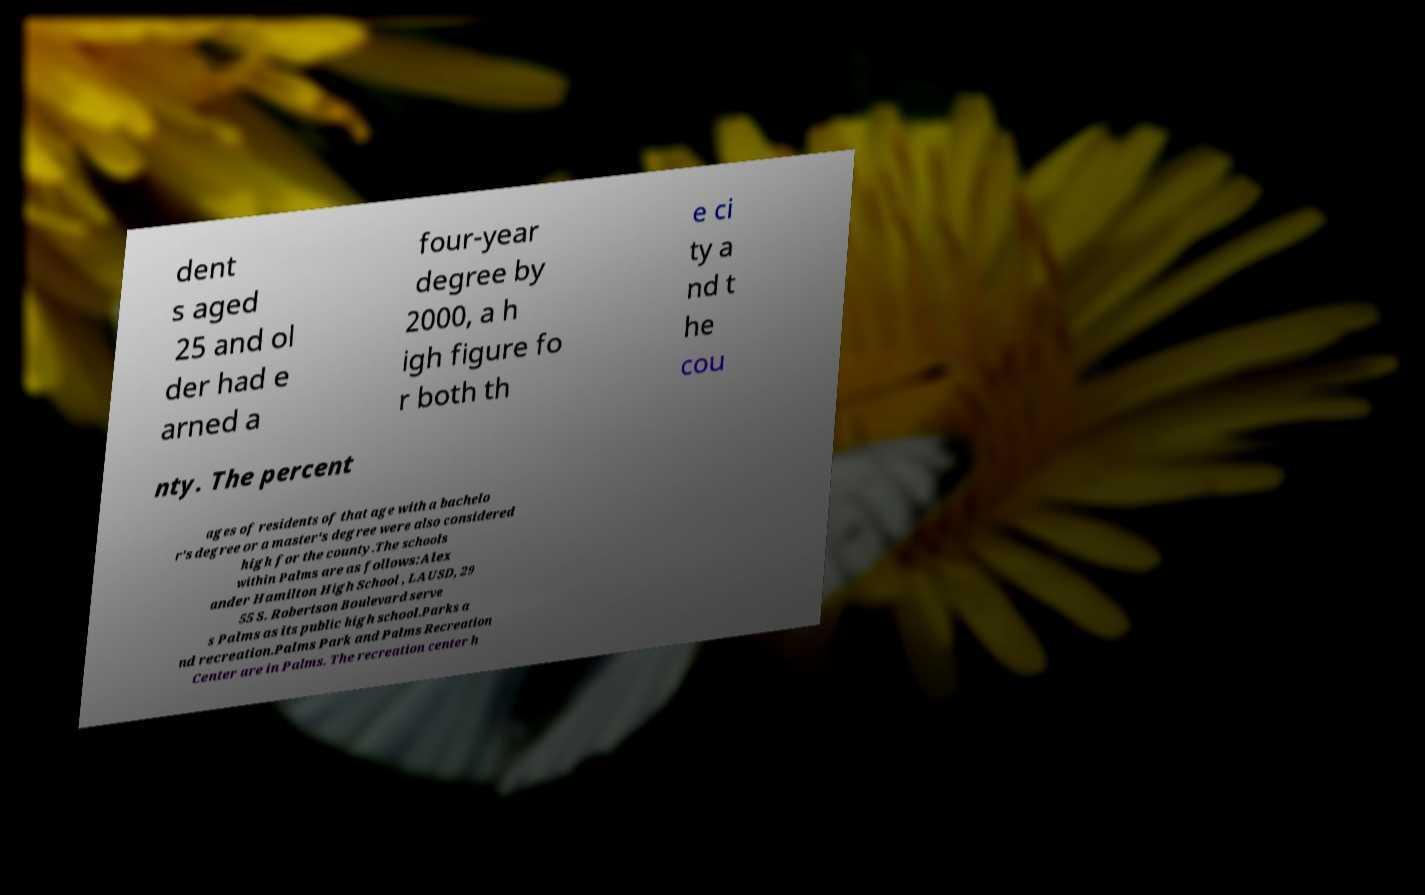For documentation purposes, I need the text within this image transcribed. Could you provide that? dent s aged 25 and ol der had e arned a four-year degree by 2000, a h igh figure fo r both th e ci ty a nd t he cou nty. The percent ages of residents of that age with a bachelo r's degree or a master's degree were also considered high for the county.The schools within Palms are as follows:Alex ander Hamilton High School , LAUSD, 29 55 S. Robertson Boulevard serve s Palms as its public high school.Parks a nd recreation.Palms Park and Palms Recreation Center are in Palms. The recreation center h 